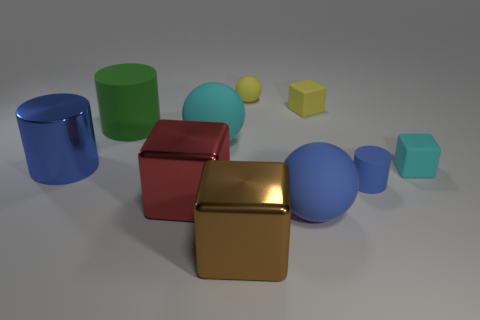Subtract all cylinders. How many objects are left? 7 Subtract all purple blocks. Subtract all tiny yellow rubber balls. How many objects are left? 9 Add 6 large brown shiny things. How many large brown shiny things are left? 7 Add 1 big blocks. How many big blocks exist? 3 Subtract 0 red cylinders. How many objects are left? 10 